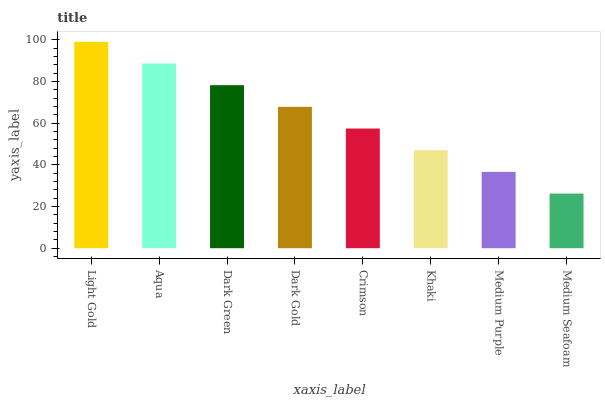Is Aqua the minimum?
Answer yes or no. No. Is Aqua the maximum?
Answer yes or no. No. Is Light Gold greater than Aqua?
Answer yes or no. Yes. Is Aqua less than Light Gold?
Answer yes or no. Yes. Is Aqua greater than Light Gold?
Answer yes or no. No. Is Light Gold less than Aqua?
Answer yes or no. No. Is Dark Gold the high median?
Answer yes or no. Yes. Is Crimson the low median?
Answer yes or no. Yes. Is Medium Seafoam the high median?
Answer yes or no. No. Is Medium Purple the low median?
Answer yes or no. No. 